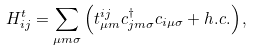Convert formula to latex. <formula><loc_0><loc_0><loc_500><loc_500>H _ { i j } ^ { t } = \sum _ { \mu m \sigma } \left ( t _ { \mu m } ^ { i j } c ^ { \dagger } _ { j m \sigma } c _ { i \mu \sigma } + h . c . \right ) ,</formula> 